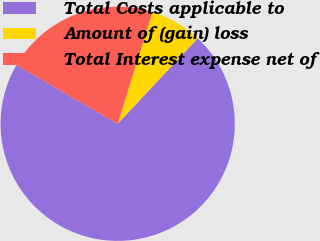Convert chart. <chart><loc_0><loc_0><loc_500><loc_500><pie_chart><fcel>Total Costs applicable to<fcel>Amount of (gain) loss<fcel>Total Interest expense net of<nl><fcel>71.39%<fcel>7.17%<fcel>21.44%<nl></chart> 